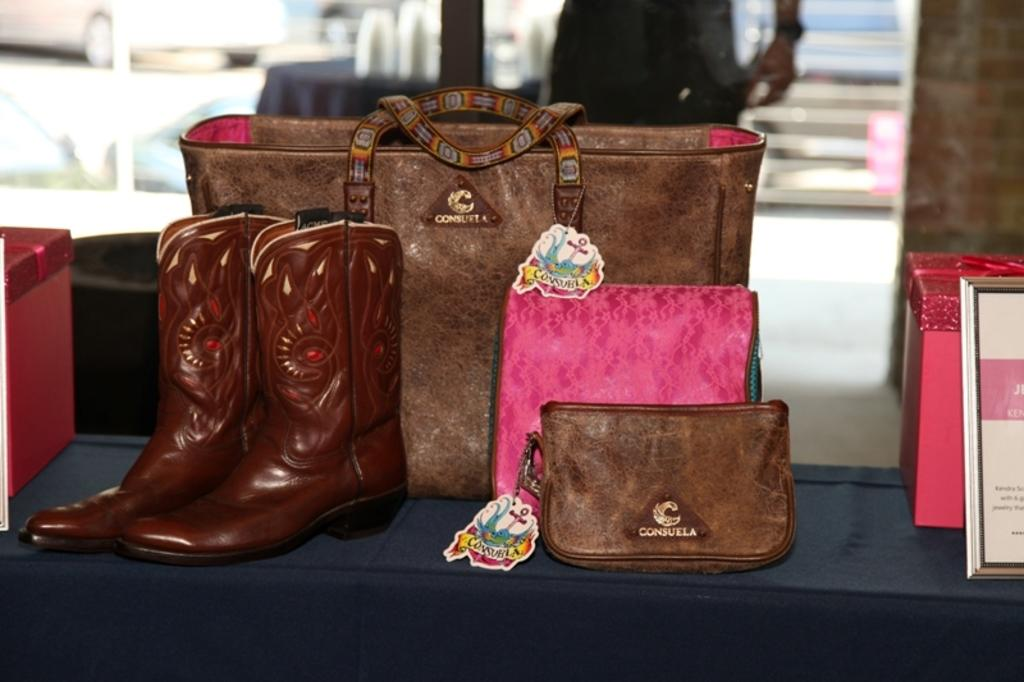What type of accessory is visible in the image? There is a handbag in the image. What other accessories can be seen in the image? There are purses and boots visible in the image. Where are the accessories placed? The items are placed on a table. What can be found on the handbags? There are tags on the handbags. What else is present besides the handbags and purses? There are boxes present besides the handbags and purses. How does the health of the handbag affect its appearance in the image? The health of the handbag is not mentioned in the image, and therefore cannot affect its appearance. 